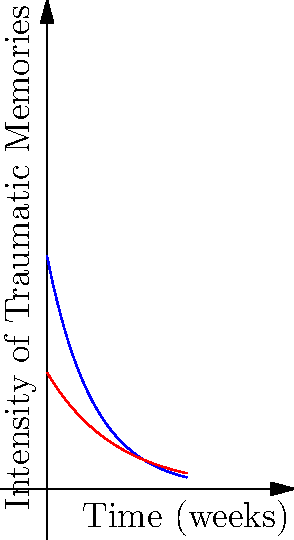The graph shows the intensity of traumatic memories before and after EMDR treatment over a 6-week period. The blue curve represents the intensity before treatment, given by the function $f(x) = 10e^{-x/2}$, and the red curve represents the intensity after treatment, given by $g(x) = 5e^{-x/3}$, where $x$ is time in weeks. Calculate the difference in the areas under these two curves from week 0 to week 6. This difference represents the reduction in overall traumatic memory intensity due to EMDR treatment. To solve this problem, we need to:

1) Find the area under the blue curve (before EMDR) from 0 to 6 weeks.
2) Find the area under the red curve (after EMDR) from 0 to 6 weeks.
3) Calculate the difference between these areas.

Step 1: Area under the blue curve (before EMDR)
$A_1 = \int_0^6 10e^{-x/2} dx$
$= -20e^{-x/2}|_0^6$
$= -20(e^{-3} - 1) = 20 - 20e^{-3}$

Step 2: Area under the red curve (after EMDR)
$A_2 = \int_0^6 5e^{-x/3} dx$
$= -15e^{-x/3}|_0^6$
$= -15(e^{-2} - 1) = 15 - 15e^{-2}$

Step 3: Difference in areas
$\Delta A = A_1 - A_2$
$= (20 - 20e^{-3}) - (15 - 15e^{-2})$
$= 5 - 20e^{-3} + 15e^{-2}$

Using a calculator for the exponential terms:
$\Delta A \approx 5 - 20(0.0498) + 15(0.1353)$
$\approx 5 - 0.996 + 2.0295$
$\approx 6.0335$
Answer: $6.0335$ 